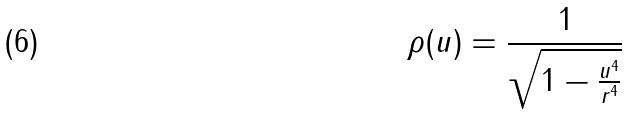<formula> <loc_0><loc_0><loc_500><loc_500>\rho ( u ) = \frac { 1 } { \sqrt { 1 - \frac { u ^ { 4 } } { r ^ { 4 } } } }</formula> 